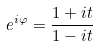Convert formula to latex. <formula><loc_0><loc_0><loc_500><loc_500>e ^ { i \varphi } = \frac { 1 + i t } { 1 - i t }</formula> 